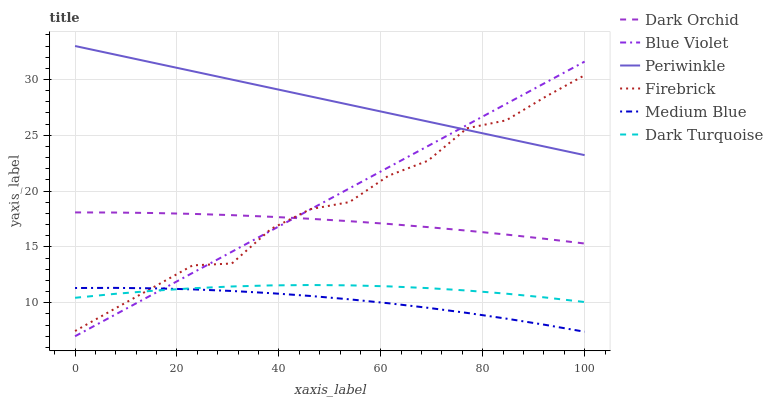Does Medium Blue have the minimum area under the curve?
Answer yes or no. Yes. Does Periwinkle have the maximum area under the curve?
Answer yes or no. Yes. Does Firebrick have the minimum area under the curve?
Answer yes or no. No. Does Firebrick have the maximum area under the curve?
Answer yes or no. No. Is Periwinkle the smoothest?
Answer yes or no. Yes. Is Firebrick the roughest?
Answer yes or no. Yes. Is Medium Blue the smoothest?
Answer yes or no. No. Is Medium Blue the roughest?
Answer yes or no. No. Does Blue Violet have the lowest value?
Answer yes or no. Yes. Does Firebrick have the lowest value?
Answer yes or no. No. Does Periwinkle have the highest value?
Answer yes or no. Yes. Does Firebrick have the highest value?
Answer yes or no. No. Is Dark Turquoise less than Dark Orchid?
Answer yes or no. Yes. Is Dark Orchid greater than Dark Turquoise?
Answer yes or no. Yes. Does Dark Turquoise intersect Blue Violet?
Answer yes or no. Yes. Is Dark Turquoise less than Blue Violet?
Answer yes or no. No. Is Dark Turquoise greater than Blue Violet?
Answer yes or no. No. Does Dark Turquoise intersect Dark Orchid?
Answer yes or no. No. 